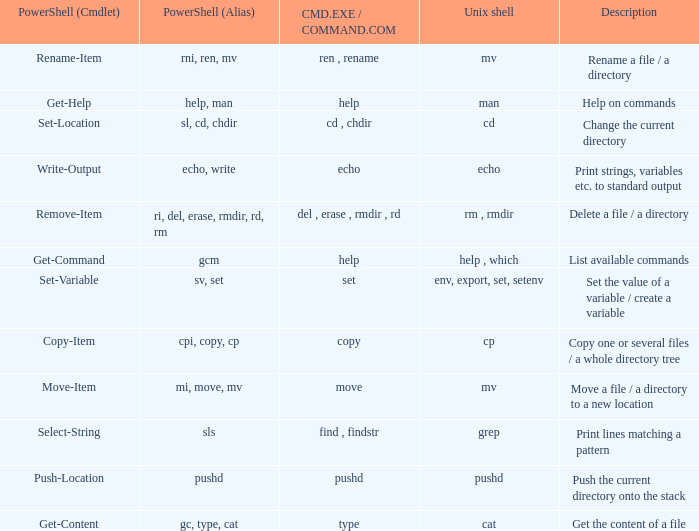When the cmd.exe / command.com is type, what are all associated values for powershell (cmdlet)? Get-Content. 